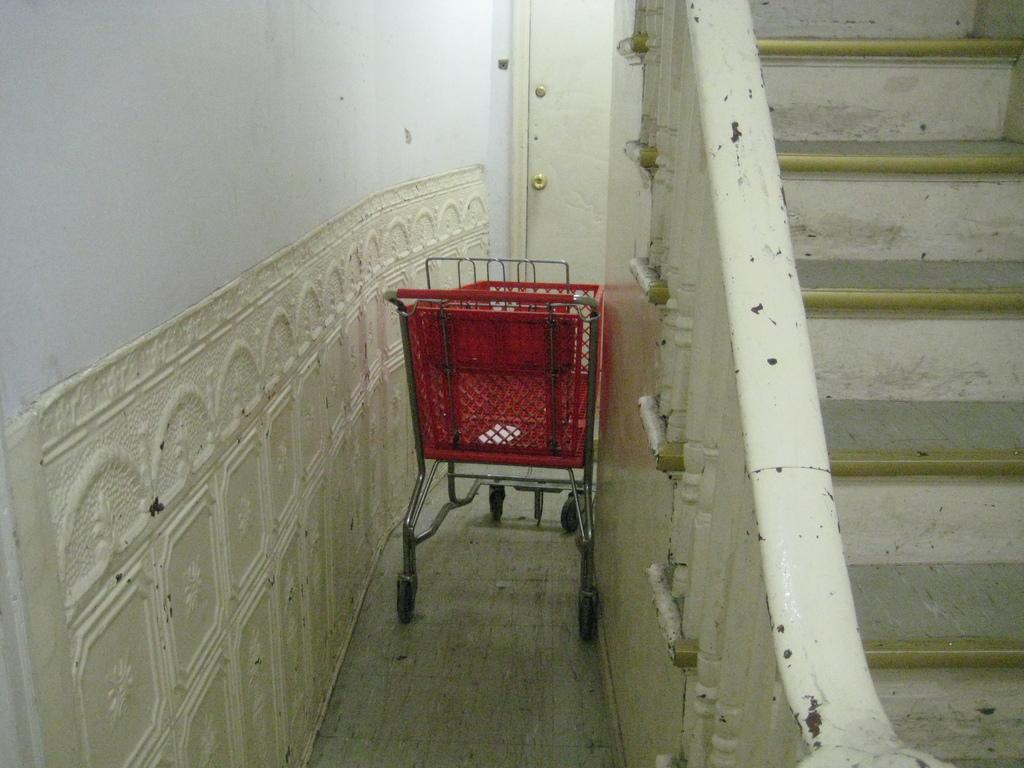What object is located in the image? There is a shopping cart in the image. Where is the shopping cart situated? The shopping cart is between walls. What architectural feature can be seen on the right side of the image? There is a staircase on the right side of the image. What type of work is being done in the image? There is no indication of any work being done in the image; it primarily features a shopping cart between walls and a staircase on the right side. 